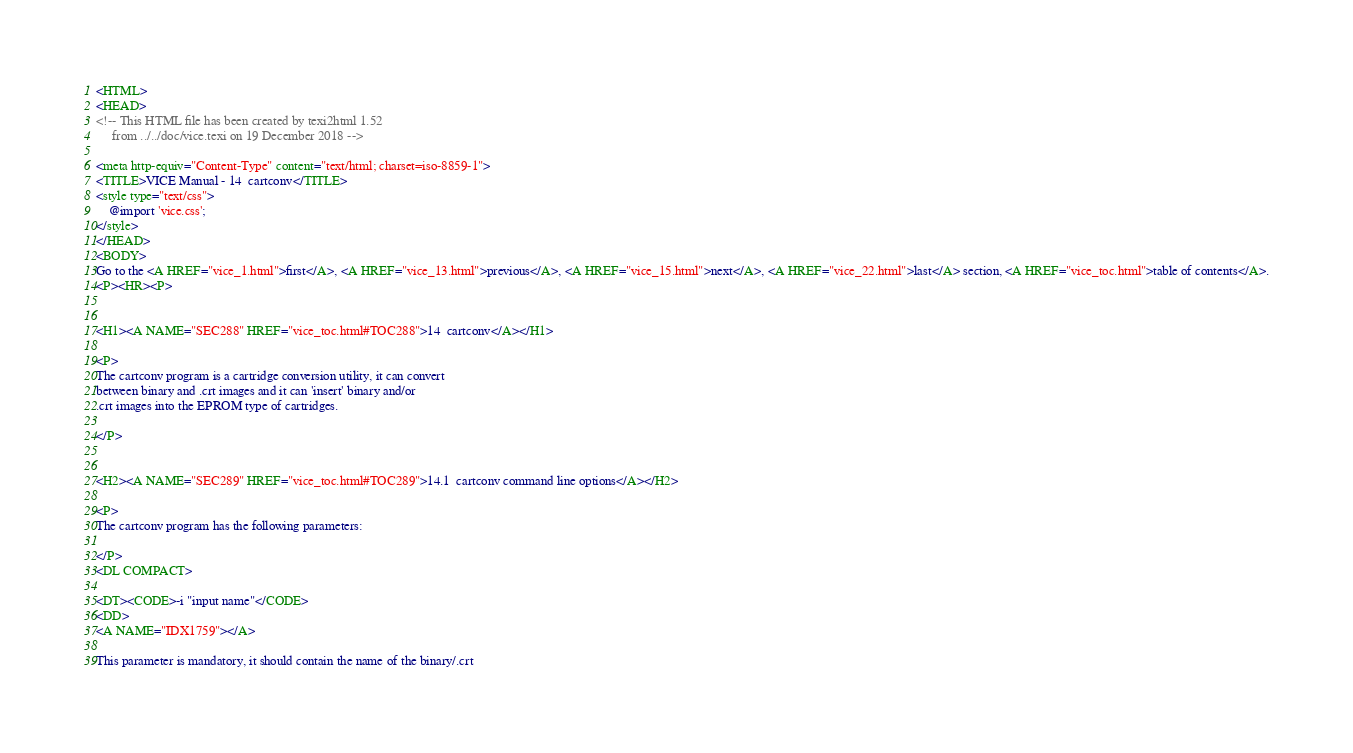<code> <loc_0><loc_0><loc_500><loc_500><_HTML_><HTML>
<HEAD>
<!-- This HTML file has been created by texi2html 1.52
     from ../../doc/vice.texi on 19 December 2018 -->

<meta http-equiv="Content-Type" content="text/html; charset=iso-8859-1">
<TITLE>VICE Manual - 14  cartconv</TITLE>
<style type="text/css">
    @import 'vice.css';
</style>
</HEAD>
<BODY>
Go to the <A HREF="vice_1.html">first</A>, <A HREF="vice_13.html">previous</A>, <A HREF="vice_15.html">next</A>, <A HREF="vice_22.html">last</A> section, <A HREF="vice_toc.html">table of contents</A>.
<P><HR><P>


<H1><A NAME="SEC288" HREF="vice_toc.html#TOC288">14  cartconv</A></H1>

<P>
The cartconv program is a cartridge conversion utility, it can convert
between binary and .crt images and it can 'insert' binary and/or
.crt images into the EPROM type of cartridges.

</P>


<H2><A NAME="SEC289" HREF="vice_toc.html#TOC289">14.1  cartconv command line options</A></H2>

<P>
The cartconv program has the following parameters:

</P>
<DL COMPACT>

<DT><CODE>-i "input name"</CODE>
<DD>
<A NAME="IDX1759"></A>
 
This parameter is mandatory, it should contain the name of the binary/.crt</code> 